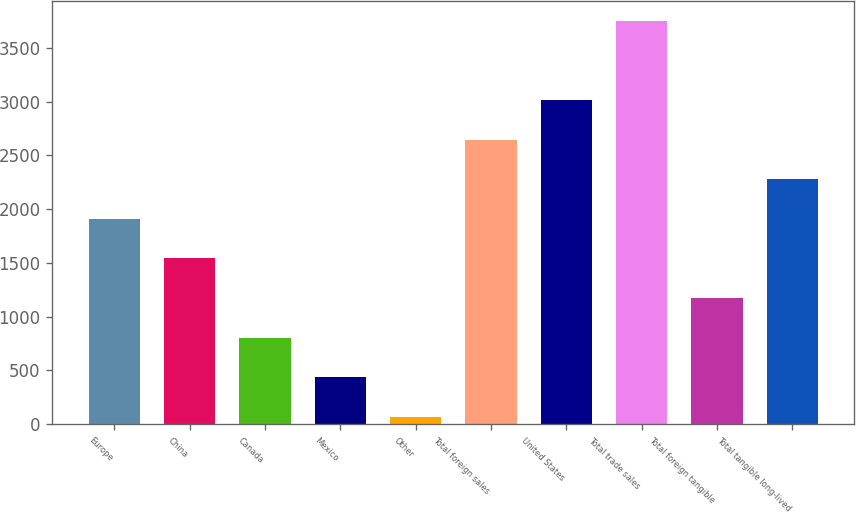Convert chart to OTSL. <chart><loc_0><loc_0><loc_500><loc_500><bar_chart><fcel>Europe<fcel>China<fcel>Canada<fcel>Mexico<fcel>Other<fcel>Total foreign sales<fcel>United States<fcel>Total trade sales<fcel>Total foreign tangible<fcel>Total tangible long-lived<nl><fcel>1909.65<fcel>1541.6<fcel>805.5<fcel>437.45<fcel>69.4<fcel>2645.75<fcel>3013.8<fcel>3749.9<fcel>1173.55<fcel>2277.7<nl></chart> 